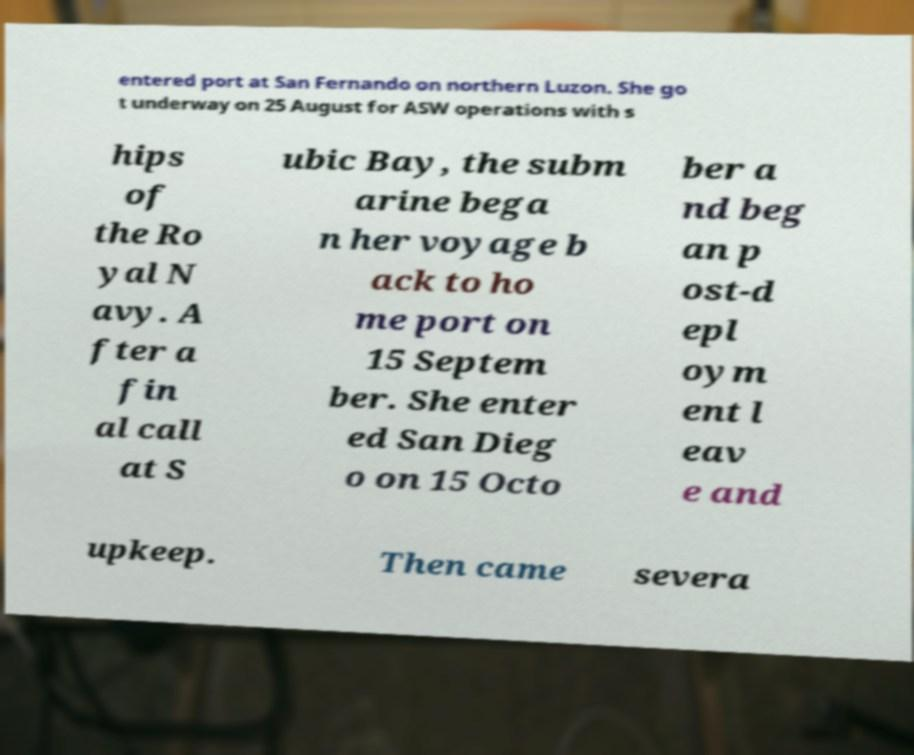Please read and relay the text visible in this image. What does it say? entered port at San Fernando on northern Luzon. She go t underway on 25 August for ASW operations with s hips of the Ro yal N avy. A fter a fin al call at S ubic Bay, the subm arine bega n her voyage b ack to ho me port on 15 Septem ber. She enter ed San Dieg o on 15 Octo ber a nd beg an p ost-d epl oym ent l eav e and upkeep. Then came severa 